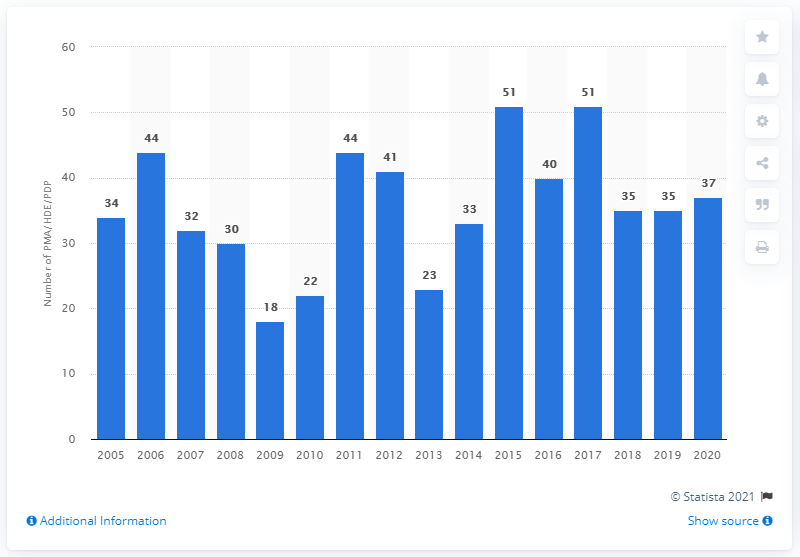Give some essential details in this illustration. In 2020, 37 new PMA/HDE were approved. 